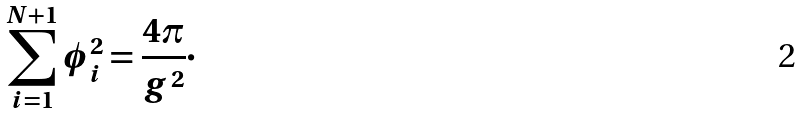<formula> <loc_0><loc_0><loc_500><loc_500>\sum _ { i = 1 } ^ { N + 1 } \phi _ { i } ^ { 2 } = \frac { 4 \pi } { g ^ { 2 } } \cdot</formula> 